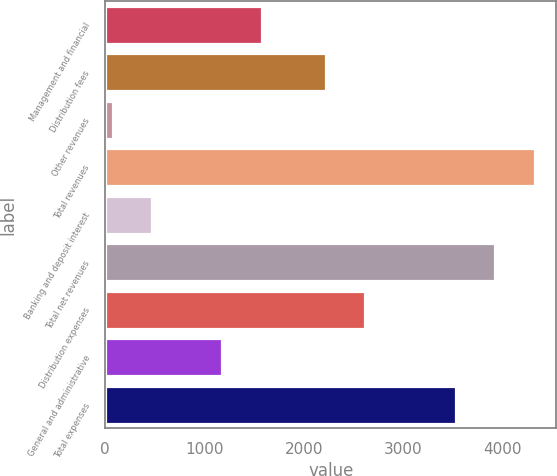Convert chart to OTSL. <chart><loc_0><loc_0><loc_500><loc_500><bar_chart><fcel>Management and financial<fcel>Distribution fees<fcel>Other revenues<fcel>Total revenues<fcel>Banking and deposit interest<fcel>Total net revenues<fcel>Distribution expenses<fcel>General and administrative<fcel>Total expenses<nl><fcel>1575.7<fcel>2218<fcel>76<fcel>4321.4<fcel>472.7<fcel>3924.7<fcel>2614.7<fcel>1179<fcel>3528<nl></chart> 